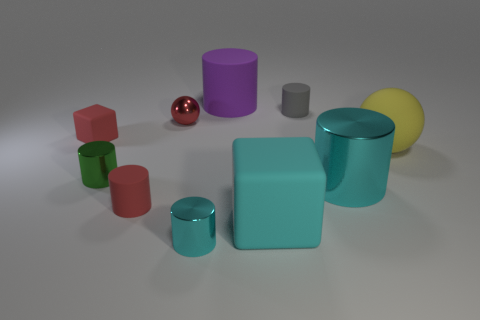Subtract all green cylinders. How many cylinders are left? 5 Subtract 1 cylinders. How many cylinders are left? 5 Subtract all small cyan metal cylinders. How many cylinders are left? 5 Subtract all blue cylinders. Subtract all yellow blocks. How many cylinders are left? 6 Subtract all cylinders. How many objects are left? 4 Add 5 gray cylinders. How many gray cylinders are left? 6 Add 5 tiny cyan cylinders. How many tiny cyan cylinders exist? 6 Subtract 0 purple cubes. How many objects are left? 10 Subtract all gray metallic spheres. Subtract all purple objects. How many objects are left? 9 